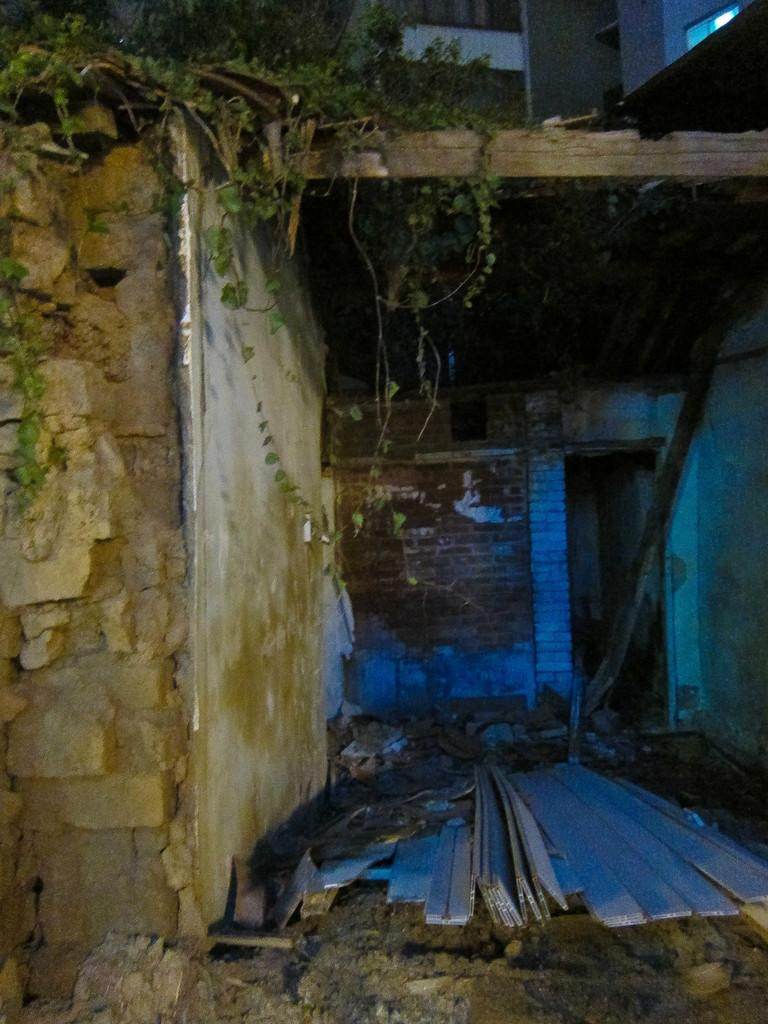What type of structure is visible in the image? There is a building in the image. Can you describe the condition of the building? The building appears to be broken or damaged. Are there any plants present on the building? Yes, there are plants on the building. What type of produce is being grown on the building in the image? There is no produce visible in the image; only plants are present on the building. 